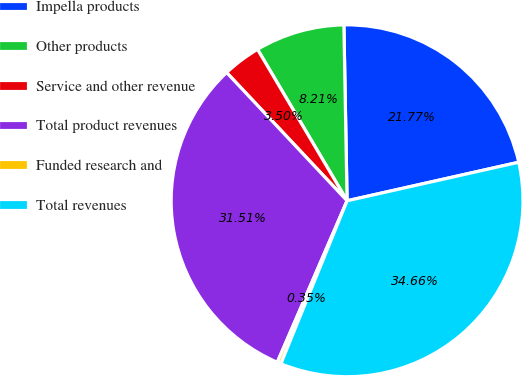Convert chart. <chart><loc_0><loc_0><loc_500><loc_500><pie_chart><fcel>Impella products<fcel>Other products<fcel>Service and other revenue<fcel>Total product revenues<fcel>Funded research and<fcel>Total revenues<nl><fcel>21.77%<fcel>8.21%<fcel>3.5%<fcel>31.5%<fcel>0.35%<fcel>34.65%<nl></chart> 